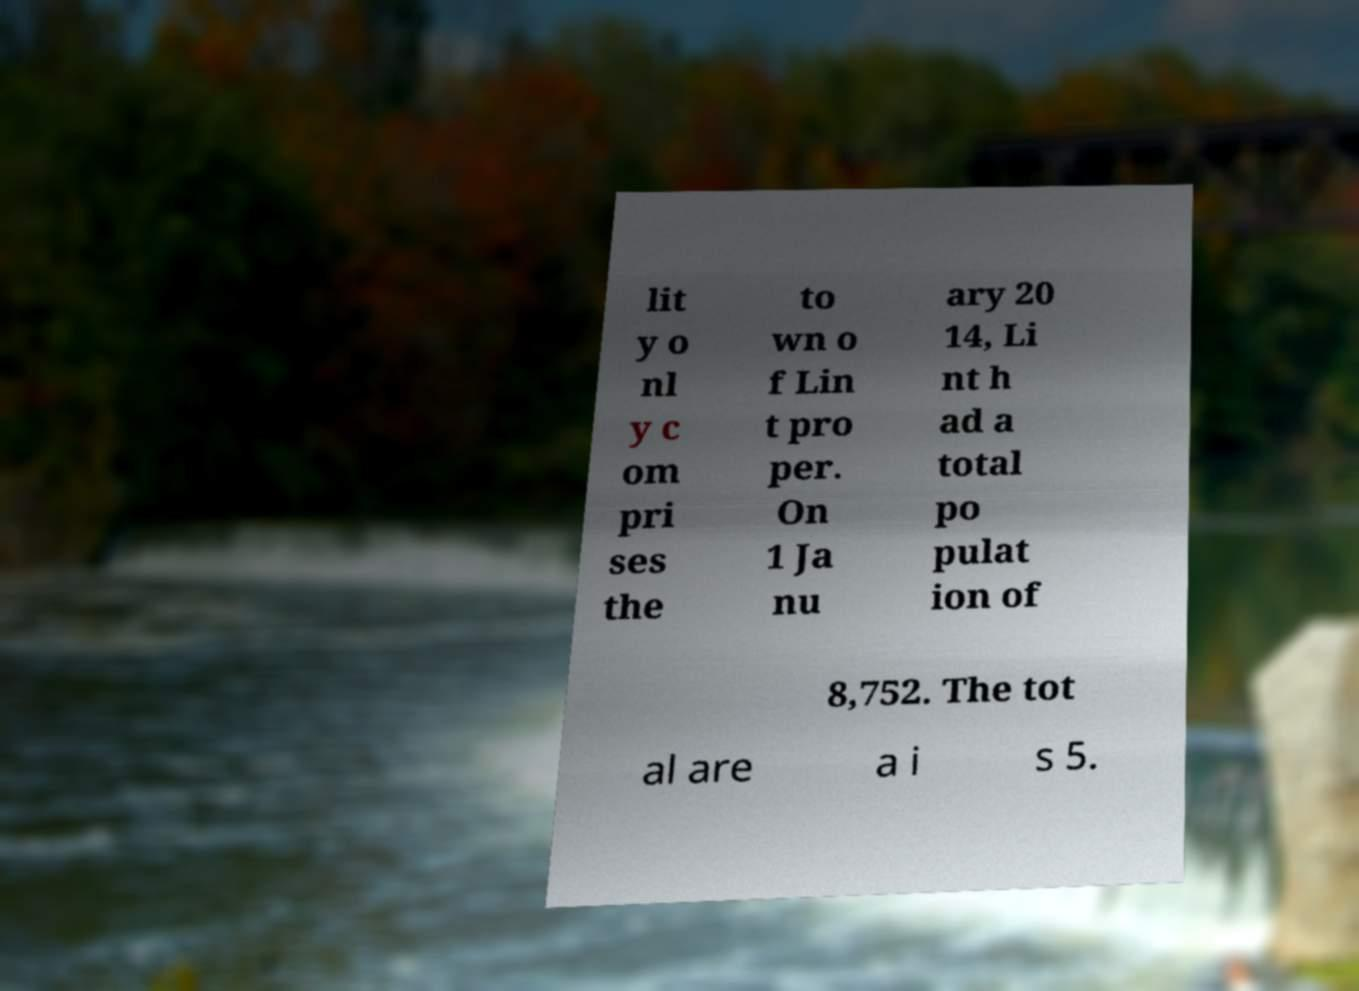There's text embedded in this image that I need extracted. Can you transcribe it verbatim? lit y o nl y c om pri ses the to wn o f Lin t pro per. On 1 Ja nu ary 20 14, Li nt h ad a total po pulat ion of 8,752. The tot al are a i s 5. 